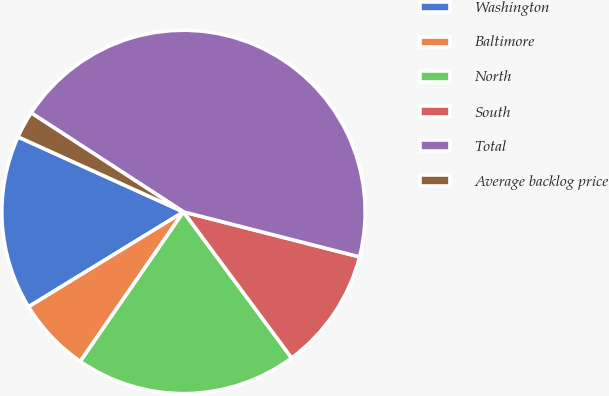<chart> <loc_0><loc_0><loc_500><loc_500><pie_chart><fcel>Washington<fcel>Baltimore<fcel>North<fcel>South<fcel>Total<fcel>Average backlog price<nl><fcel>15.52%<fcel>6.64%<fcel>19.76%<fcel>10.88%<fcel>44.81%<fcel>2.4%<nl></chart> 